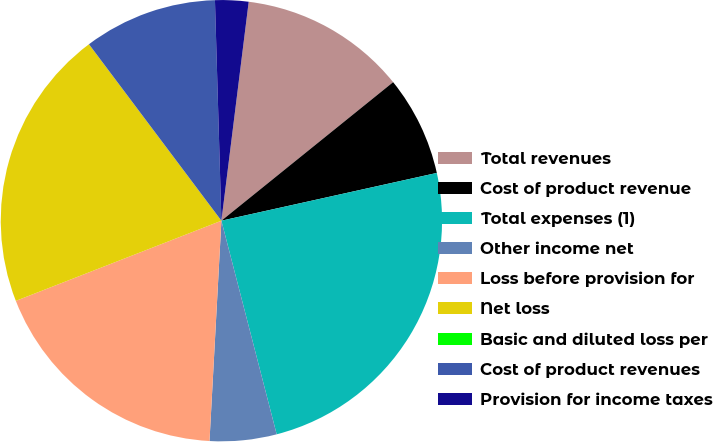Convert chart. <chart><loc_0><loc_0><loc_500><loc_500><pie_chart><fcel>Total revenues<fcel>Cost of product revenue<fcel>Total expenses (1)<fcel>Other income net<fcel>Loss before provision for<fcel>Net loss<fcel>Basic and diluted loss per<fcel>Cost of product revenues<fcel>Provision for income taxes<nl><fcel>12.22%<fcel>7.33%<fcel>24.44%<fcel>4.89%<fcel>18.22%<fcel>20.67%<fcel>0.0%<fcel>9.78%<fcel>2.44%<nl></chart> 